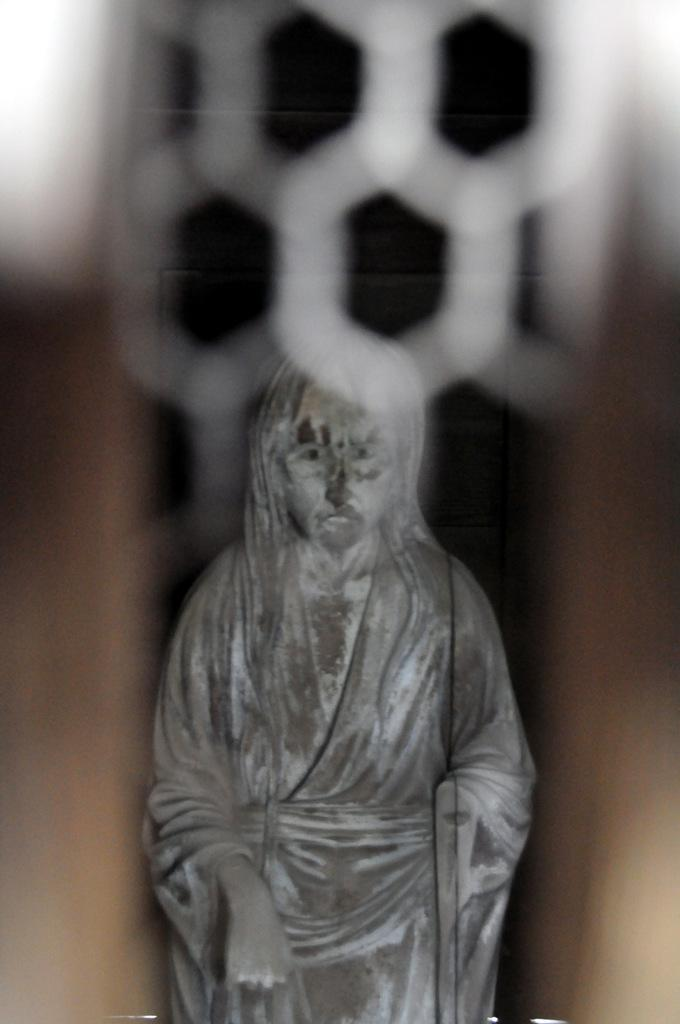What is the main subject of the image? There is a statue of a person in the image. Can you describe the background of the image? The background of the image is blurred. What type of flock can be seen flying in the background of the image? There is no flock visible in the image, as the background is blurred and does not show any birds or animals. 